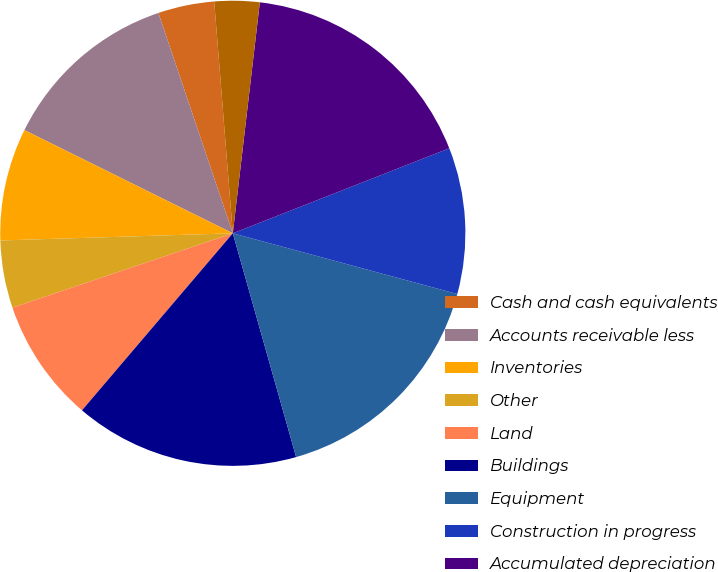<chart> <loc_0><loc_0><loc_500><loc_500><pie_chart><fcel>Cash and cash equivalents<fcel>Accounts receivable less<fcel>Inventories<fcel>Other<fcel>Land<fcel>Buildings<fcel>Equipment<fcel>Construction in progress<fcel>Accumulated depreciation<fcel>Investments of insurance<nl><fcel>3.91%<fcel>12.5%<fcel>7.81%<fcel>4.69%<fcel>8.59%<fcel>15.62%<fcel>16.41%<fcel>10.16%<fcel>17.19%<fcel>3.13%<nl></chart> 